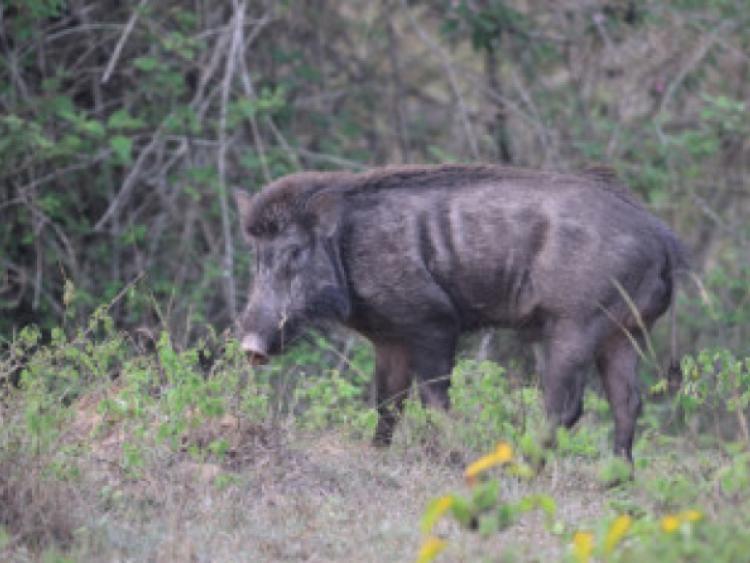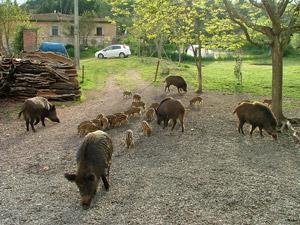The first image is the image on the left, the second image is the image on the right. Examine the images to the left and right. Is the description "An image contains no more than 8 hogs, with at least half standing facing forward." accurate? Answer yes or no. No. The first image is the image on the left, the second image is the image on the right. Assess this claim about the two images: "there are no more than three boars in one of the images". Correct or not? Answer yes or no. Yes. 